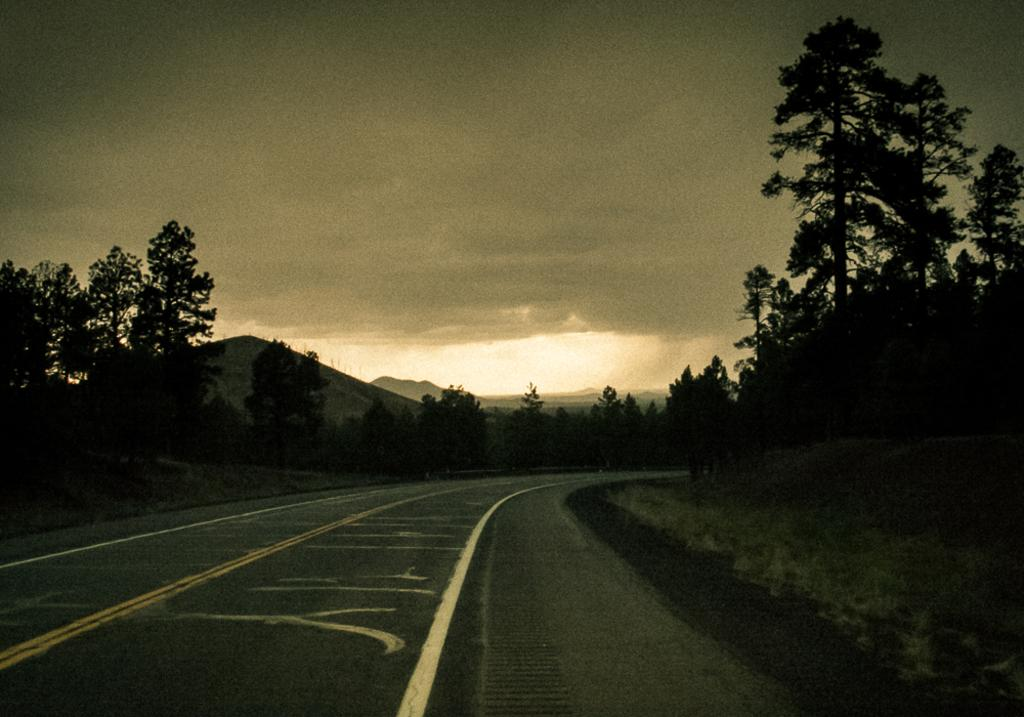What type of surface can be seen in the image? There is a road in the image. What is visible beneath the road? There is ground visible in the image. What type of vegetation is present in the image? There are trees in the image. What type of geographical feature can be seen in the distance? There are mountains in the image. What is visible in the background of the image? The sky is visible in the background of the image. What can be seen in the sky? There are clouds in the sky. How many sons are visible in the image? There is no son present in the image. Is there a fire visible in the image? There is no fire present in the image. 